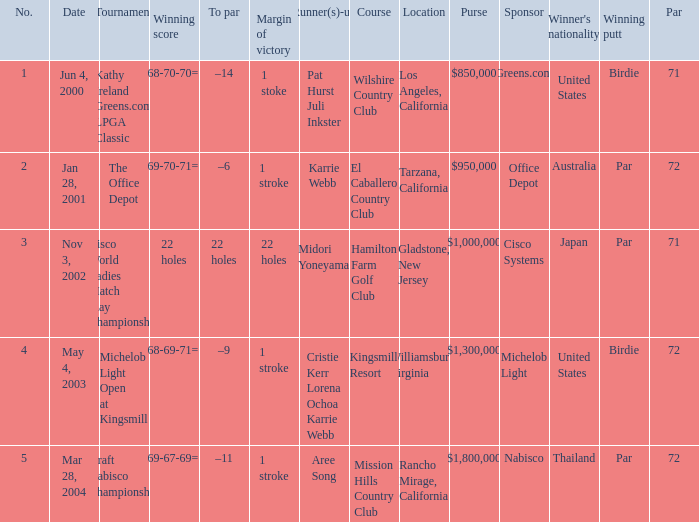What date were the runner ups pat hurst juli inkster? Jun 4, 2000. 